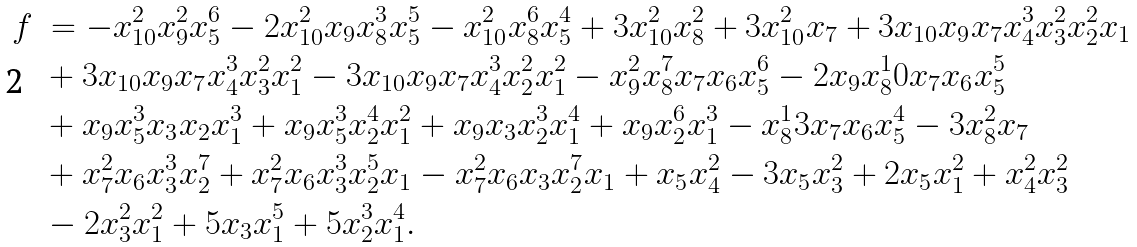<formula> <loc_0><loc_0><loc_500><loc_500>f \ & = - x _ { 1 0 } ^ { 2 } x _ { 9 } ^ { 2 } x _ { 5 } ^ { 6 } - 2 x _ { 1 0 } ^ { 2 } x _ { 9 } x _ { 8 } ^ { 3 } x _ { 5 } ^ { 5 } - x _ { 1 0 } ^ { 2 } x _ { 8 } ^ { 6 } x _ { 5 } ^ { 4 } + 3 x _ { 1 0 } ^ { 2 } x _ { 8 } ^ { 2 } + 3 x _ { 1 0 } ^ { 2 } x _ { 7 } + 3 x _ { 1 0 } x _ { 9 } x _ { 7 } x _ { 4 } ^ { 3 } x _ { 3 } ^ { 2 } x _ { 2 } ^ { 2 } x _ { 1 } \\ & + 3 x _ { 1 0 } x _ { 9 } x _ { 7 } x _ { 4 } ^ { 3 } x _ { 3 } ^ { 2 } x _ { 1 } ^ { 2 } - 3 x _ { 1 0 } x _ { 9 } x _ { 7 } x _ { 4 } ^ { 3 } x _ { 2 } ^ { 2 } x _ { 1 } ^ { 2 } - x _ { 9 } ^ { 2 } x _ { 8 } ^ { 7 } x _ { 7 } x _ { 6 } x _ { 5 } ^ { 6 } - 2 x _ { 9 } x _ { 8 } ^ { 1 } 0 x _ { 7 } x _ { 6 } x _ { 5 } ^ { 5 } \\ & + x _ { 9 } x _ { 5 } ^ { 3 } x _ { 3 } x _ { 2 } x _ { 1 } ^ { 3 } + x _ { 9 } x _ { 5 } ^ { 3 } x _ { 2 } ^ { 4 } x _ { 1 } ^ { 2 } + x _ { 9 } x _ { 3 } x _ { 2 } ^ { 3 } x _ { 1 } ^ { 4 } + x _ { 9 } x _ { 2 } ^ { 6 } x _ { 1 } ^ { 3 } - x _ { 8 } ^ { 1 } 3 x _ { 7 } x _ { 6 } x _ { 5 } ^ { 4 } - 3 x _ { 8 } ^ { 2 } x _ { 7 } \\ & + x _ { 7 } ^ { 2 } x _ { 6 } x _ { 3 } ^ { 3 } x _ { 2 } ^ { 7 } + x _ { 7 } ^ { 2 } x _ { 6 } x _ { 3 } ^ { 3 } x _ { 2 } ^ { 5 } x _ { 1 } - x _ { 7 } ^ { 2 } x _ { 6 } x _ { 3 } x _ { 2 } ^ { 7 } x _ { 1 } + x _ { 5 } x _ { 4 } ^ { 2 } - 3 x _ { 5 } x _ { 3 } ^ { 2 } + 2 x _ { 5 } x _ { 1 } ^ { 2 } + x _ { 4 } ^ { 2 } x _ { 3 } ^ { 2 } \\ & - 2 x _ { 3 } ^ { 2 } x _ { 1 } ^ { 2 } + 5 x _ { 3 } x _ { 1 } ^ { 5 } + 5 x _ { 2 } ^ { 3 } x _ { 1 } ^ { 4 } .</formula> 